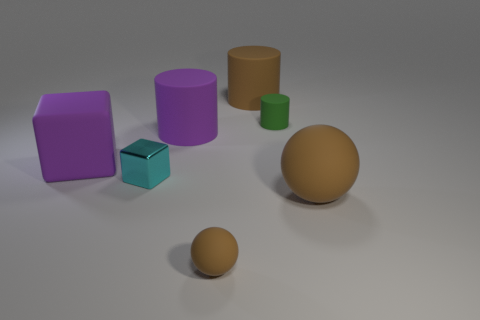Subtract all blue cubes. Subtract all green cylinders. How many cubes are left? 2 Add 2 blue shiny cylinders. How many objects exist? 9 Subtract all cylinders. How many objects are left? 4 Add 2 big brown objects. How many big brown objects are left? 4 Add 4 small gray rubber things. How many small gray rubber things exist? 4 Subtract 1 purple cubes. How many objects are left? 6 Subtract all tiny cylinders. Subtract all big blue shiny cubes. How many objects are left? 6 